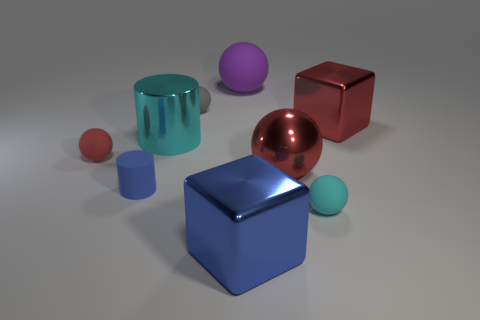Subtract all brown balls. Subtract all blue cylinders. How many balls are left? 5 Add 1 large balls. How many objects exist? 10 Subtract all cylinders. How many objects are left? 7 Add 5 tiny gray rubber things. How many tiny gray rubber things are left? 6 Add 7 metal blocks. How many metal blocks exist? 9 Subtract 0 yellow blocks. How many objects are left? 9 Subtract all small cyan things. Subtract all blue metallic things. How many objects are left? 7 